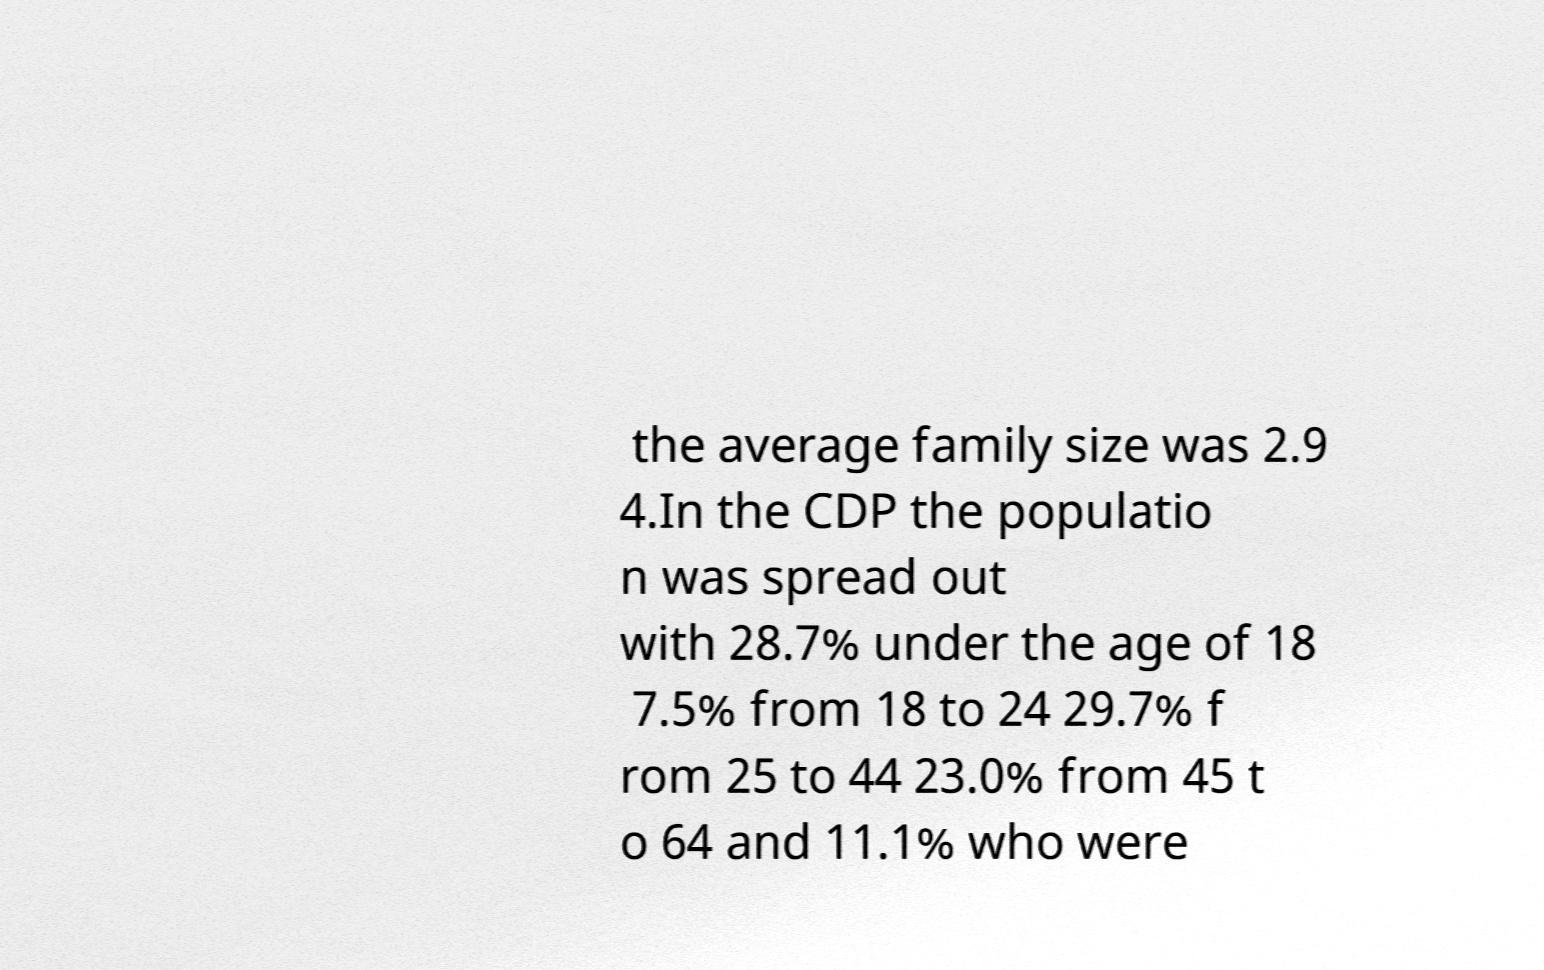Please read and relay the text visible in this image. What does it say? the average family size was 2.9 4.In the CDP the populatio n was spread out with 28.7% under the age of 18 7.5% from 18 to 24 29.7% f rom 25 to 44 23.0% from 45 t o 64 and 11.1% who were 